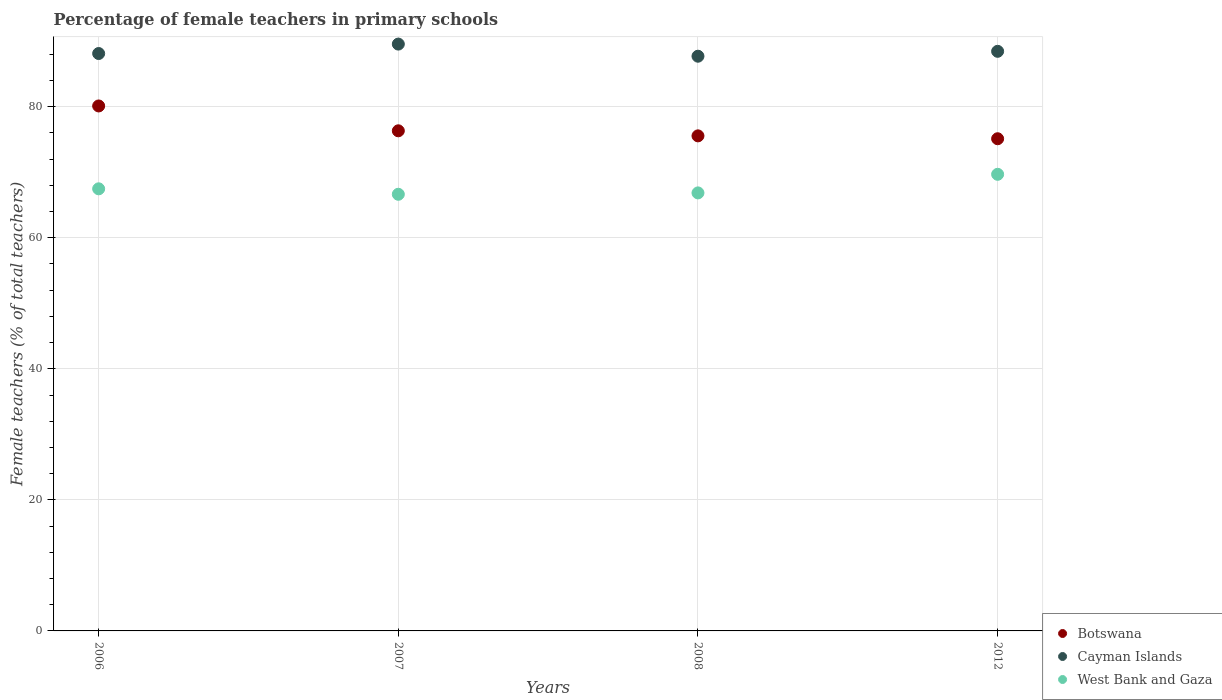Is the number of dotlines equal to the number of legend labels?
Make the answer very short. Yes. What is the percentage of female teachers in Botswana in 2008?
Keep it short and to the point. 75.55. Across all years, what is the maximum percentage of female teachers in Cayman Islands?
Provide a short and direct response. 89.55. Across all years, what is the minimum percentage of female teachers in Cayman Islands?
Keep it short and to the point. 87.7. In which year was the percentage of female teachers in Botswana minimum?
Your answer should be very brief. 2012. What is the total percentage of female teachers in Botswana in the graph?
Offer a terse response. 307.08. What is the difference between the percentage of female teachers in Botswana in 2006 and that in 2008?
Offer a terse response. 4.56. What is the difference between the percentage of female teachers in West Bank and Gaza in 2008 and the percentage of female teachers in Botswana in 2012?
Give a very brief answer. -8.27. What is the average percentage of female teachers in Botswana per year?
Ensure brevity in your answer.  76.77. In the year 2006, what is the difference between the percentage of female teachers in Botswana and percentage of female teachers in Cayman Islands?
Offer a very short reply. -8. What is the ratio of the percentage of female teachers in West Bank and Gaza in 2008 to that in 2012?
Your answer should be very brief. 0.96. Is the percentage of female teachers in West Bank and Gaza in 2006 less than that in 2007?
Offer a terse response. No. Is the difference between the percentage of female teachers in Botswana in 2006 and 2008 greater than the difference between the percentage of female teachers in Cayman Islands in 2006 and 2008?
Offer a terse response. Yes. What is the difference between the highest and the second highest percentage of female teachers in Botswana?
Your answer should be compact. 3.79. What is the difference between the highest and the lowest percentage of female teachers in Cayman Islands?
Your response must be concise. 1.85. Is it the case that in every year, the sum of the percentage of female teachers in West Bank and Gaza and percentage of female teachers in Cayman Islands  is greater than the percentage of female teachers in Botswana?
Offer a terse response. Yes. Does the percentage of female teachers in Cayman Islands monotonically increase over the years?
Offer a very short reply. No. Is the percentage of female teachers in West Bank and Gaza strictly greater than the percentage of female teachers in Botswana over the years?
Make the answer very short. No. Does the graph contain grids?
Make the answer very short. Yes. How are the legend labels stacked?
Ensure brevity in your answer.  Vertical. What is the title of the graph?
Provide a succinct answer. Percentage of female teachers in primary schools. What is the label or title of the X-axis?
Provide a succinct answer. Years. What is the label or title of the Y-axis?
Your response must be concise. Female teachers (% of total teachers). What is the Female teachers (% of total teachers) in Botswana in 2006?
Your answer should be very brief. 80.11. What is the Female teachers (% of total teachers) in Cayman Islands in 2006?
Give a very brief answer. 88.11. What is the Female teachers (% of total teachers) of West Bank and Gaza in 2006?
Your response must be concise. 67.47. What is the Female teachers (% of total teachers) in Botswana in 2007?
Provide a short and direct response. 76.32. What is the Female teachers (% of total teachers) of Cayman Islands in 2007?
Offer a very short reply. 89.55. What is the Female teachers (% of total teachers) of West Bank and Gaza in 2007?
Keep it short and to the point. 66.63. What is the Female teachers (% of total teachers) in Botswana in 2008?
Your answer should be compact. 75.55. What is the Female teachers (% of total teachers) of Cayman Islands in 2008?
Your response must be concise. 87.7. What is the Female teachers (% of total teachers) of West Bank and Gaza in 2008?
Ensure brevity in your answer.  66.84. What is the Female teachers (% of total teachers) in Botswana in 2012?
Give a very brief answer. 75.11. What is the Female teachers (% of total teachers) in Cayman Islands in 2012?
Ensure brevity in your answer.  88.45. What is the Female teachers (% of total teachers) in West Bank and Gaza in 2012?
Keep it short and to the point. 69.68. Across all years, what is the maximum Female teachers (% of total teachers) of Botswana?
Offer a very short reply. 80.11. Across all years, what is the maximum Female teachers (% of total teachers) in Cayman Islands?
Keep it short and to the point. 89.55. Across all years, what is the maximum Female teachers (% of total teachers) of West Bank and Gaza?
Provide a short and direct response. 69.68. Across all years, what is the minimum Female teachers (% of total teachers) of Botswana?
Offer a very short reply. 75.11. Across all years, what is the minimum Female teachers (% of total teachers) of Cayman Islands?
Your response must be concise. 87.7. Across all years, what is the minimum Female teachers (% of total teachers) of West Bank and Gaza?
Provide a succinct answer. 66.63. What is the total Female teachers (% of total teachers) in Botswana in the graph?
Provide a short and direct response. 307.08. What is the total Female teachers (% of total teachers) of Cayman Islands in the graph?
Give a very brief answer. 353.82. What is the total Female teachers (% of total teachers) of West Bank and Gaza in the graph?
Offer a very short reply. 270.62. What is the difference between the Female teachers (% of total teachers) of Botswana in 2006 and that in 2007?
Keep it short and to the point. 3.79. What is the difference between the Female teachers (% of total teachers) of Cayman Islands in 2006 and that in 2007?
Your response must be concise. -1.44. What is the difference between the Female teachers (% of total teachers) of West Bank and Gaza in 2006 and that in 2007?
Ensure brevity in your answer.  0.83. What is the difference between the Female teachers (% of total teachers) of Botswana in 2006 and that in 2008?
Your response must be concise. 4.56. What is the difference between the Female teachers (% of total teachers) in Cayman Islands in 2006 and that in 2008?
Your answer should be compact. 0.41. What is the difference between the Female teachers (% of total teachers) in West Bank and Gaza in 2006 and that in 2008?
Provide a short and direct response. 0.62. What is the difference between the Female teachers (% of total teachers) in Botswana in 2006 and that in 2012?
Give a very brief answer. 5. What is the difference between the Female teachers (% of total teachers) of Cayman Islands in 2006 and that in 2012?
Ensure brevity in your answer.  -0.34. What is the difference between the Female teachers (% of total teachers) of West Bank and Gaza in 2006 and that in 2012?
Your answer should be very brief. -2.21. What is the difference between the Female teachers (% of total teachers) of Botswana in 2007 and that in 2008?
Your answer should be very brief. 0.77. What is the difference between the Female teachers (% of total teachers) of Cayman Islands in 2007 and that in 2008?
Make the answer very short. 1.85. What is the difference between the Female teachers (% of total teachers) of West Bank and Gaza in 2007 and that in 2008?
Make the answer very short. -0.21. What is the difference between the Female teachers (% of total teachers) in Botswana in 2007 and that in 2012?
Offer a terse response. 1.21. What is the difference between the Female teachers (% of total teachers) in Cayman Islands in 2007 and that in 2012?
Provide a short and direct response. 1.1. What is the difference between the Female teachers (% of total teachers) of West Bank and Gaza in 2007 and that in 2012?
Give a very brief answer. -3.05. What is the difference between the Female teachers (% of total teachers) of Botswana in 2008 and that in 2012?
Offer a terse response. 0.44. What is the difference between the Female teachers (% of total teachers) in Cayman Islands in 2008 and that in 2012?
Your answer should be very brief. -0.75. What is the difference between the Female teachers (% of total teachers) of West Bank and Gaza in 2008 and that in 2012?
Offer a terse response. -2.84. What is the difference between the Female teachers (% of total teachers) of Botswana in 2006 and the Female teachers (% of total teachers) of Cayman Islands in 2007?
Give a very brief answer. -9.44. What is the difference between the Female teachers (% of total teachers) in Botswana in 2006 and the Female teachers (% of total teachers) in West Bank and Gaza in 2007?
Your answer should be compact. 13.48. What is the difference between the Female teachers (% of total teachers) in Cayman Islands in 2006 and the Female teachers (% of total teachers) in West Bank and Gaza in 2007?
Keep it short and to the point. 21.48. What is the difference between the Female teachers (% of total teachers) in Botswana in 2006 and the Female teachers (% of total teachers) in Cayman Islands in 2008?
Your answer should be very brief. -7.59. What is the difference between the Female teachers (% of total teachers) in Botswana in 2006 and the Female teachers (% of total teachers) in West Bank and Gaza in 2008?
Offer a very short reply. 13.27. What is the difference between the Female teachers (% of total teachers) of Cayman Islands in 2006 and the Female teachers (% of total teachers) of West Bank and Gaza in 2008?
Your response must be concise. 21.27. What is the difference between the Female teachers (% of total teachers) in Botswana in 2006 and the Female teachers (% of total teachers) in Cayman Islands in 2012?
Provide a succinct answer. -8.34. What is the difference between the Female teachers (% of total teachers) in Botswana in 2006 and the Female teachers (% of total teachers) in West Bank and Gaza in 2012?
Keep it short and to the point. 10.43. What is the difference between the Female teachers (% of total teachers) in Cayman Islands in 2006 and the Female teachers (% of total teachers) in West Bank and Gaza in 2012?
Your response must be concise. 18.43. What is the difference between the Female teachers (% of total teachers) of Botswana in 2007 and the Female teachers (% of total teachers) of Cayman Islands in 2008?
Make the answer very short. -11.38. What is the difference between the Female teachers (% of total teachers) of Botswana in 2007 and the Female teachers (% of total teachers) of West Bank and Gaza in 2008?
Your answer should be very brief. 9.48. What is the difference between the Female teachers (% of total teachers) in Cayman Islands in 2007 and the Female teachers (% of total teachers) in West Bank and Gaza in 2008?
Ensure brevity in your answer.  22.71. What is the difference between the Female teachers (% of total teachers) of Botswana in 2007 and the Female teachers (% of total teachers) of Cayman Islands in 2012?
Ensure brevity in your answer.  -12.13. What is the difference between the Female teachers (% of total teachers) of Botswana in 2007 and the Female teachers (% of total teachers) of West Bank and Gaza in 2012?
Ensure brevity in your answer.  6.64. What is the difference between the Female teachers (% of total teachers) in Cayman Islands in 2007 and the Female teachers (% of total teachers) in West Bank and Gaza in 2012?
Keep it short and to the point. 19.87. What is the difference between the Female teachers (% of total teachers) in Botswana in 2008 and the Female teachers (% of total teachers) in Cayman Islands in 2012?
Make the answer very short. -12.9. What is the difference between the Female teachers (% of total teachers) of Botswana in 2008 and the Female teachers (% of total teachers) of West Bank and Gaza in 2012?
Your answer should be very brief. 5.87. What is the difference between the Female teachers (% of total teachers) of Cayman Islands in 2008 and the Female teachers (% of total teachers) of West Bank and Gaza in 2012?
Your answer should be compact. 18.02. What is the average Female teachers (% of total teachers) in Botswana per year?
Ensure brevity in your answer.  76.77. What is the average Female teachers (% of total teachers) in Cayman Islands per year?
Your response must be concise. 88.45. What is the average Female teachers (% of total teachers) in West Bank and Gaza per year?
Offer a very short reply. 67.66. In the year 2006, what is the difference between the Female teachers (% of total teachers) of Botswana and Female teachers (% of total teachers) of Cayman Islands?
Your response must be concise. -8. In the year 2006, what is the difference between the Female teachers (% of total teachers) in Botswana and Female teachers (% of total teachers) in West Bank and Gaza?
Give a very brief answer. 12.64. In the year 2006, what is the difference between the Female teachers (% of total teachers) of Cayman Islands and Female teachers (% of total teachers) of West Bank and Gaza?
Offer a terse response. 20.65. In the year 2007, what is the difference between the Female teachers (% of total teachers) of Botswana and Female teachers (% of total teachers) of Cayman Islands?
Offer a very short reply. -13.23. In the year 2007, what is the difference between the Female teachers (% of total teachers) of Botswana and Female teachers (% of total teachers) of West Bank and Gaza?
Keep it short and to the point. 9.69. In the year 2007, what is the difference between the Female teachers (% of total teachers) in Cayman Islands and Female teachers (% of total teachers) in West Bank and Gaza?
Make the answer very short. 22.92. In the year 2008, what is the difference between the Female teachers (% of total teachers) in Botswana and Female teachers (% of total teachers) in Cayman Islands?
Give a very brief answer. -12.16. In the year 2008, what is the difference between the Female teachers (% of total teachers) of Botswana and Female teachers (% of total teachers) of West Bank and Gaza?
Provide a short and direct response. 8.7. In the year 2008, what is the difference between the Female teachers (% of total teachers) in Cayman Islands and Female teachers (% of total teachers) in West Bank and Gaza?
Your response must be concise. 20.86. In the year 2012, what is the difference between the Female teachers (% of total teachers) of Botswana and Female teachers (% of total teachers) of Cayman Islands?
Offer a very short reply. -13.34. In the year 2012, what is the difference between the Female teachers (% of total teachers) in Botswana and Female teachers (% of total teachers) in West Bank and Gaza?
Your response must be concise. 5.43. In the year 2012, what is the difference between the Female teachers (% of total teachers) of Cayman Islands and Female teachers (% of total teachers) of West Bank and Gaza?
Ensure brevity in your answer.  18.77. What is the ratio of the Female teachers (% of total teachers) of Botswana in 2006 to that in 2007?
Your answer should be compact. 1.05. What is the ratio of the Female teachers (% of total teachers) in Cayman Islands in 2006 to that in 2007?
Keep it short and to the point. 0.98. What is the ratio of the Female teachers (% of total teachers) in West Bank and Gaza in 2006 to that in 2007?
Your response must be concise. 1.01. What is the ratio of the Female teachers (% of total teachers) in Botswana in 2006 to that in 2008?
Make the answer very short. 1.06. What is the ratio of the Female teachers (% of total teachers) in Cayman Islands in 2006 to that in 2008?
Offer a very short reply. 1. What is the ratio of the Female teachers (% of total teachers) in West Bank and Gaza in 2006 to that in 2008?
Your response must be concise. 1.01. What is the ratio of the Female teachers (% of total teachers) of Botswana in 2006 to that in 2012?
Offer a very short reply. 1.07. What is the ratio of the Female teachers (% of total teachers) in West Bank and Gaza in 2006 to that in 2012?
Offer a terse response. 0.97. What is the ratio of the Female teachers (% of total teachers) in Botswana in 2007 to that in 2008?
Your answer should be compact. 1.01. What is the ratio of the Female teachers (% of total teachers) in Cayman Islands in 2007 to that in 2008?
Provide a succinct answer. 1.02. What is the ratio of the Female teachers (% of total teachers) in Botswana in 2007 to that in 2012?
Keep it short and to the point. 1.02. What is the ratio of the Female teachers (% of total teachers) in Cayman Islands in 2007 to that in 2012?
Offer a terse response. 1.01. What is the ratio of the Female teachers (% of total teachers) in West Bank and Gaza in 2007 to that in 2012?
Your response must be concise. 0.96. What is the ratio of the Female teachers (% of total teachers) of West Bank and Gaza in 2008 to that in 2012?
Offer a terse response. 0.96. What is the difference between the highest and the second highest Female teachers (% of total teachers) in Botswana?
Make the answer very short. 3.79. What is the difference between the highest and the second highest Female teachers (% of total teachers) in Cayman Islands?
Make the answer very short. 1.1. What is the difference between the highest and the second highest Female teachers (% of total teachers) of West Bank and Gaza?
Your response must be concise. 2.21. What is the difference between the highest and the lowest Female teachers (% of total teachers) in Botswana?
Provide a succinct answer. 5. What is the difference between the highest and the lowest Female teachers (% of total teachers) of Cayman Islands?
Your answer should be very brief. 1.85. What is the difference between the highest and the lowest Female teachers (% of total teachers) of West Bank and Gaza?
Your answer should be very brief. 3.05. 